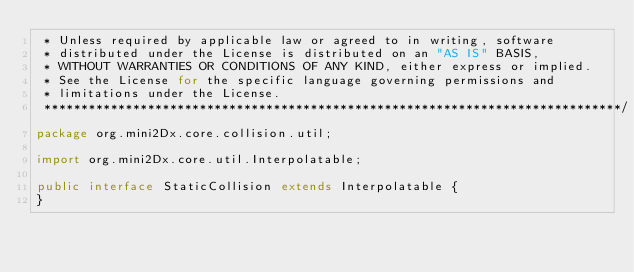Convert code to text. <code><loc_0><loc_0><loc_500><loc_500><_Java_> * Unless required by applicable law or agreed to in writing, software
 * distributed under the License is distributed on an "AS IS" BASIS,
 * WITHOUT WARRANTIES OR CONDITIONS OF ANY KIND, either express or implied.
 * See the License for the specific language governing permissions and
 * limitations under the License.
 ******************************************************************************/
package org.mini2Dx.core.collision.util;

import org.mini2Dx.core.util.Interpolatable;

public interface StaticCollision extends Interpolatable {
}
</code> 